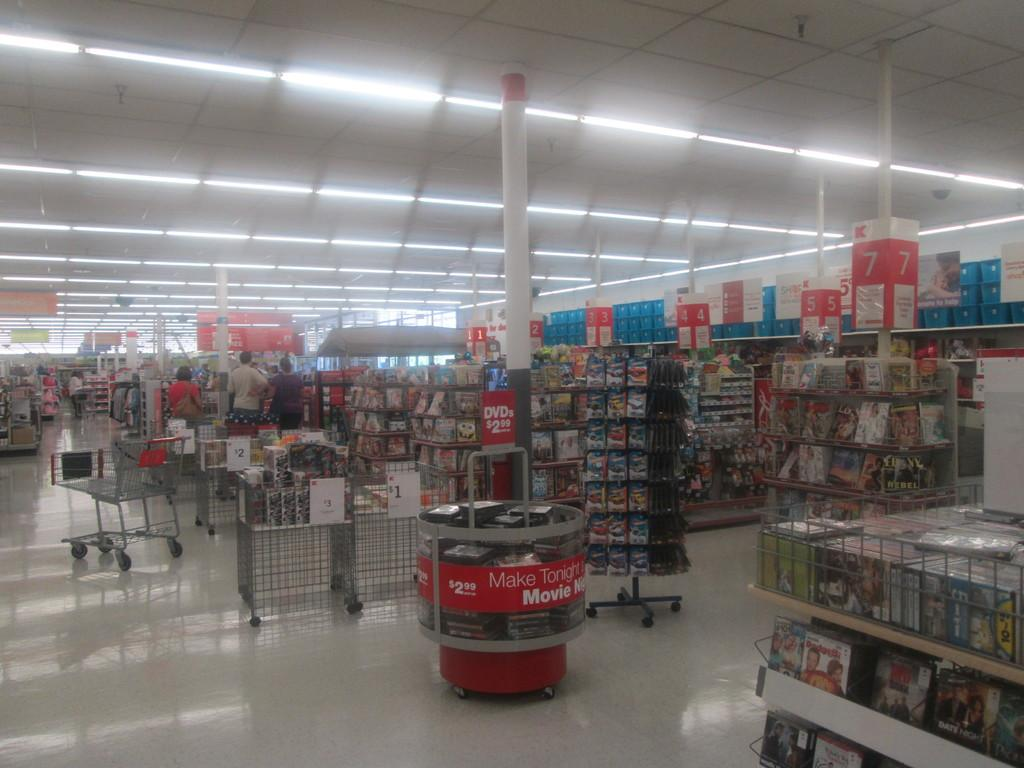What type of furniture is visible in the image? There are book racks in the image. What else can be seen in the image besides book racks? There are trolleys and people visible in the image. What might be used for illumination in the image? Lamps are present at the top side of the image. What type of establishment might the image depict? The setting appears to be a book store. How many socks are on the trolleys in the image? There are no socks present in the image; it depicts a book store setting. What type of amphibians can be seen hopping around the book racks in the image? There are no amphibians, such as frogs, present in the image; it depicts a book store setting. 